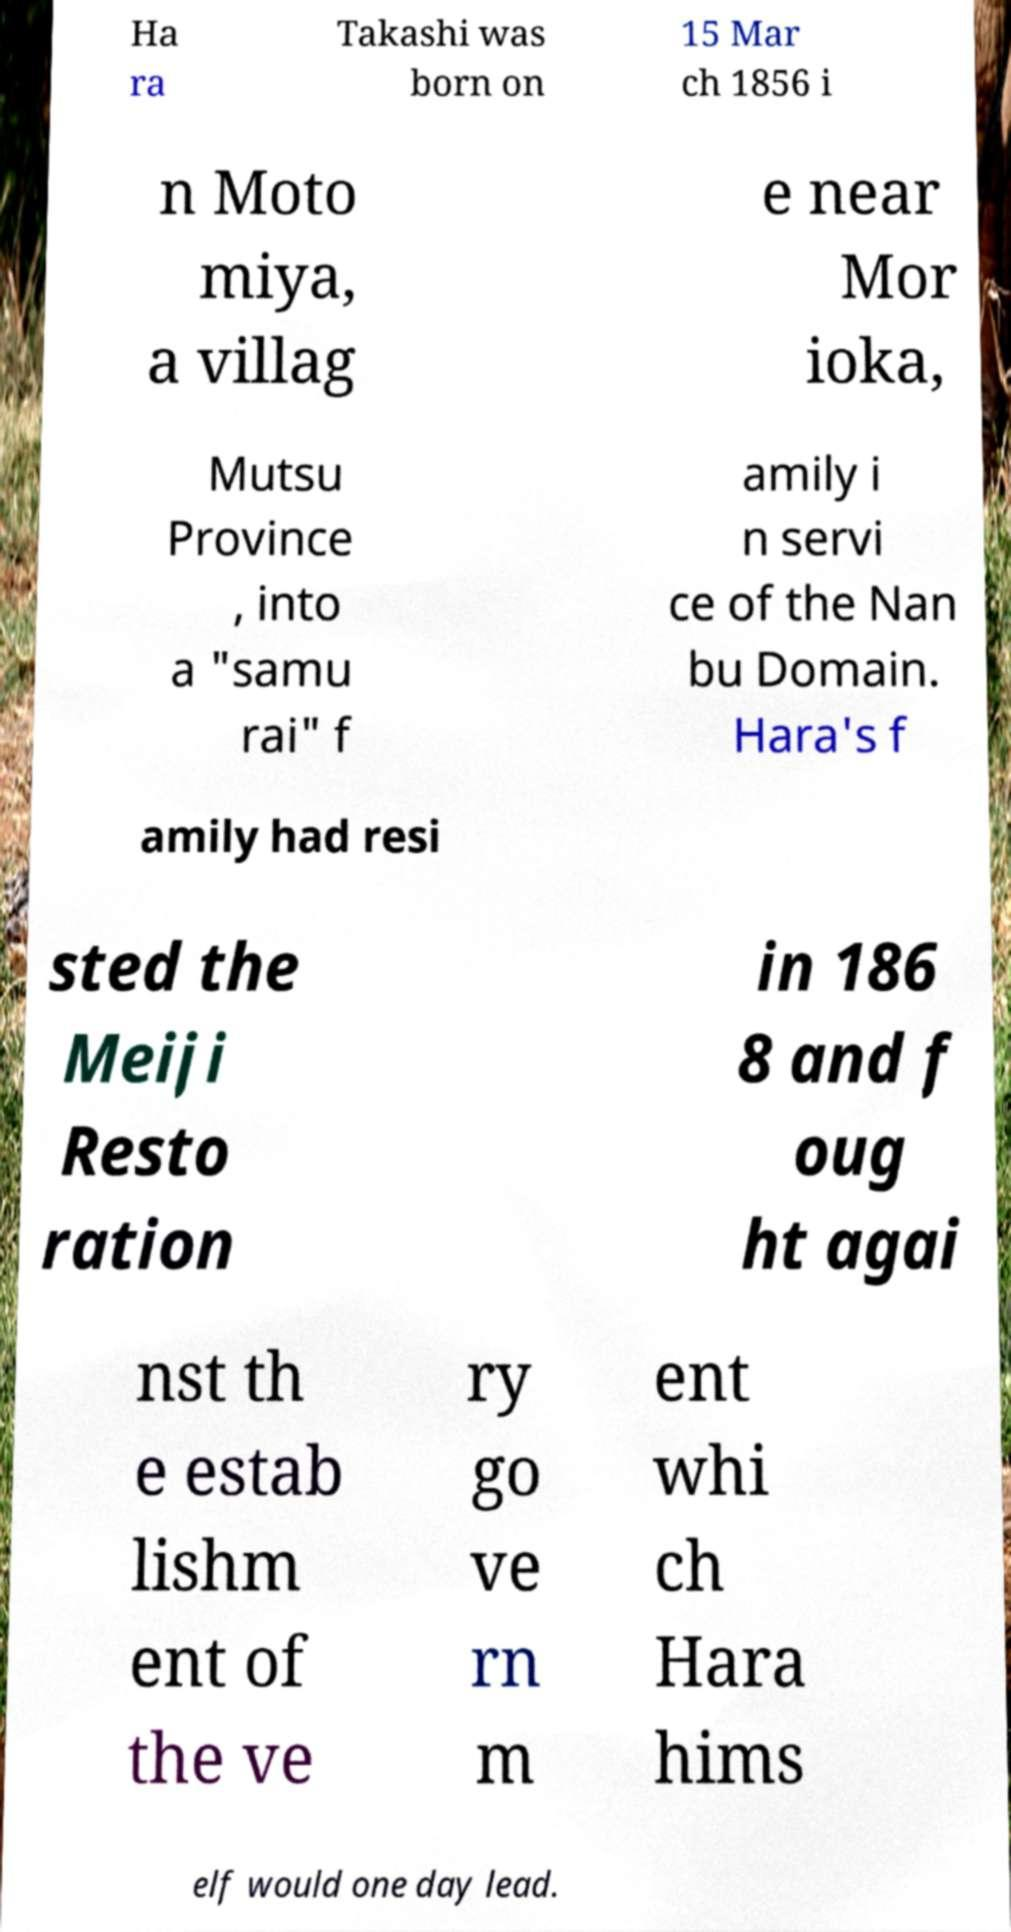Please read and relay the text visible in this image. What does it say? Ha ra Takashi was born on 15 Mar ch 1856 i n Moto miya, a villag e near Mor ioka, Mutsu Province , into a "samu rai" f amily i n servi ce of the Nan bu Domain. Hara's f amily had resi sted the Meiji Resto ration in 186 8 and f oug ht agai nst th e estab lishm ent of the ve ry go ve rn m ent whi ch Hara hims elf would one day lead. 